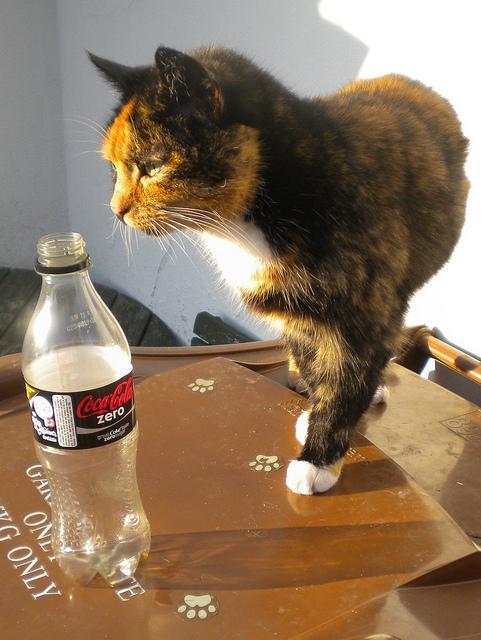How many cats are in the picture?
Give a very brief answer. 1. 